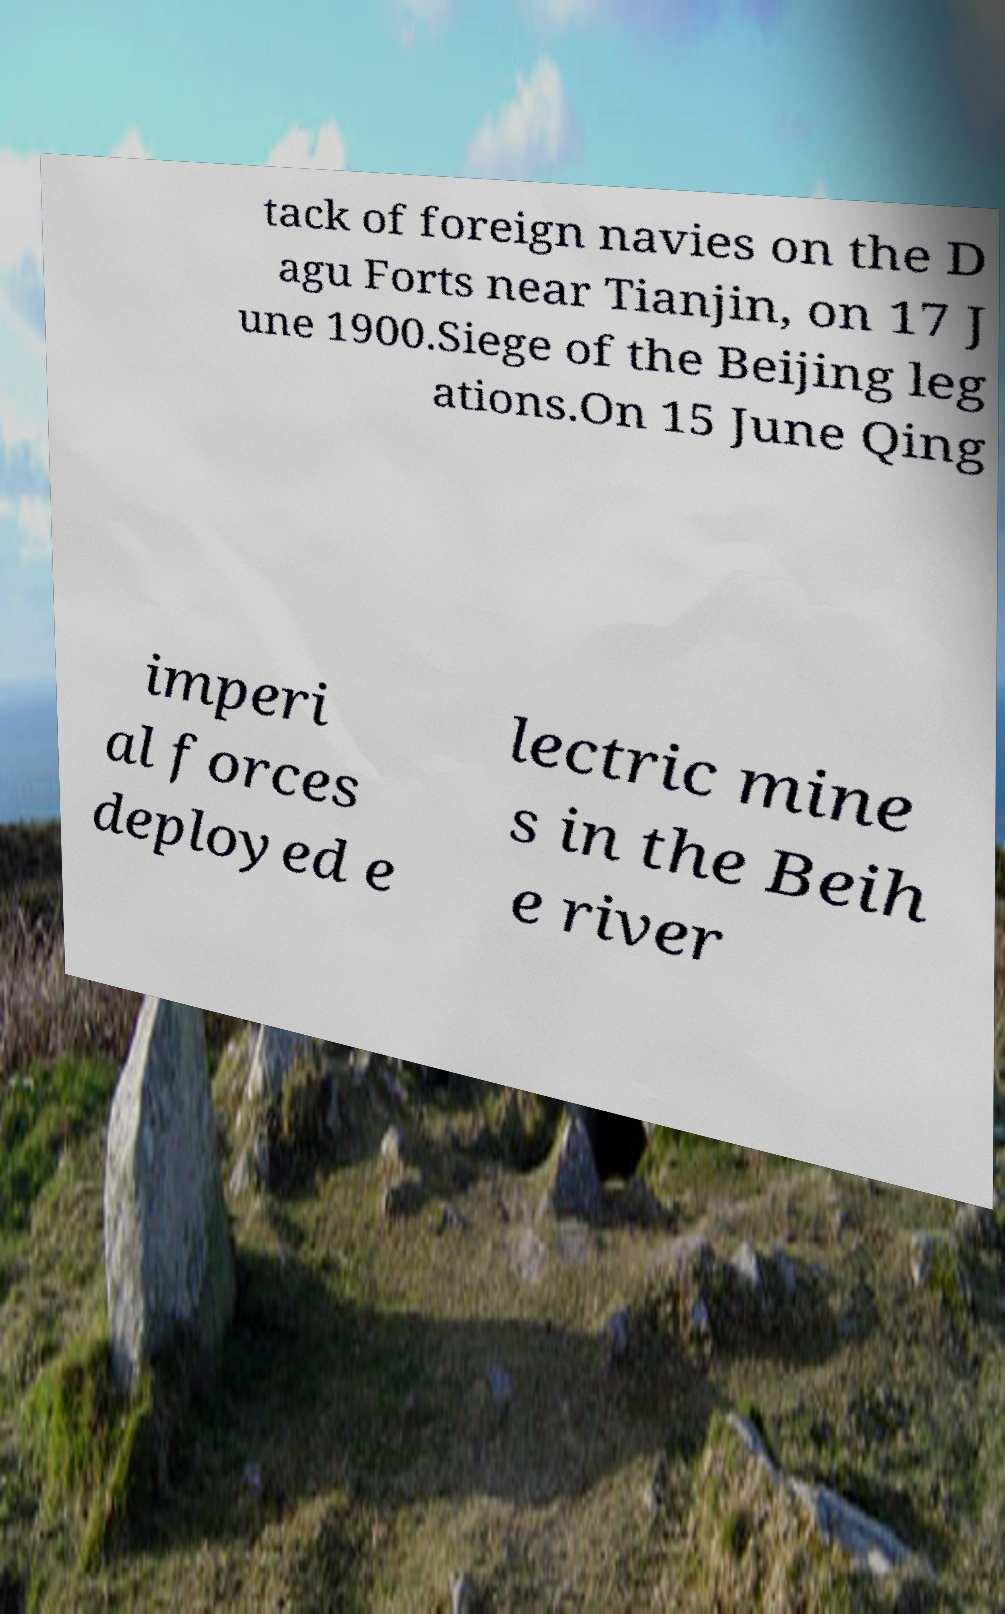Could you assist in decoding the text presented in this image and type it out clearly? tack of foreign navies on the D agu Forts near Tianjin, on 17 J une 1900.Siege of the Beijing leg ations.On 15 June Qing imperi al forces deployed e lectric mine s in the Beih e river 